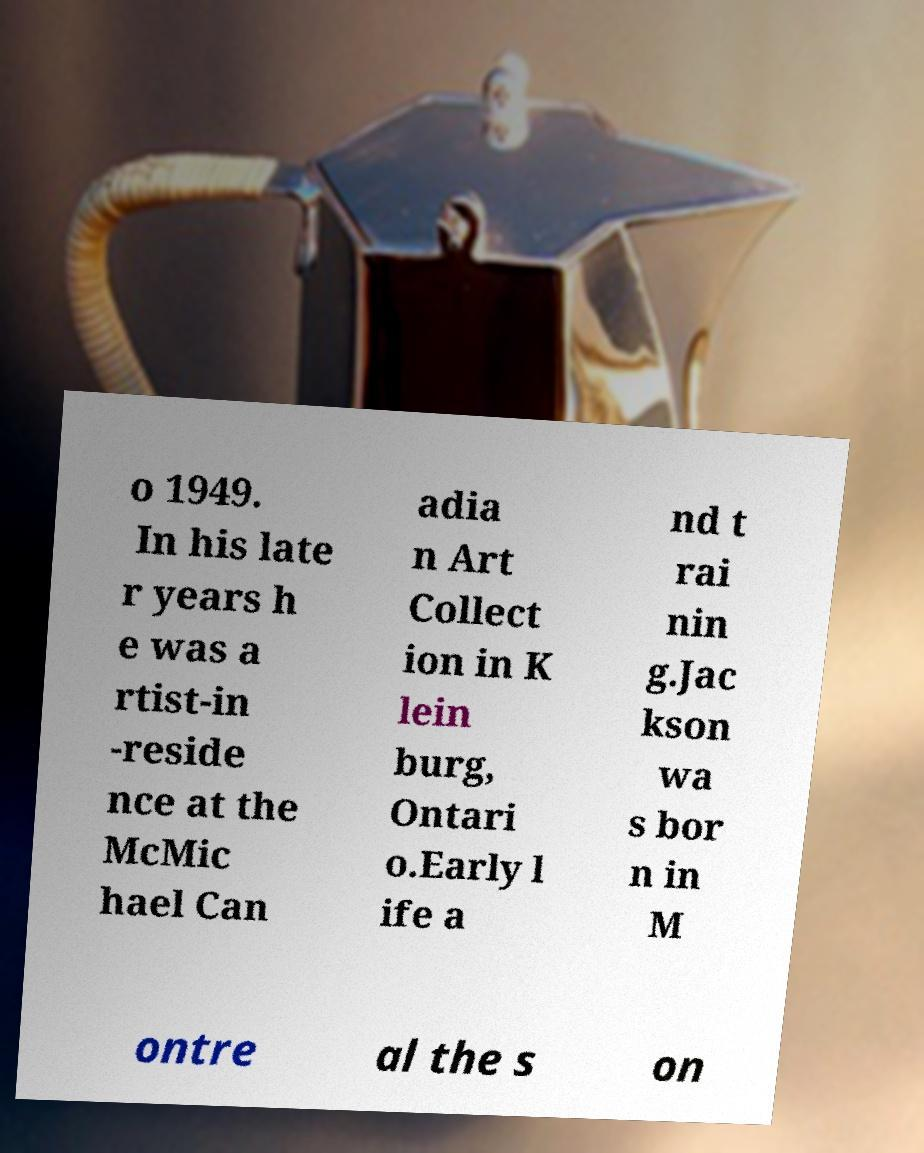Please identify and transcribe the text found in this image. o 1949. In his late r years h e was a rtist-in -reside nce at the McMic hael Can adia n Art Collect ion in K lein burg, Ontari o.Early l ife a nd t rai nin g.Jac kson wa s bor n in M ontre al the s on 